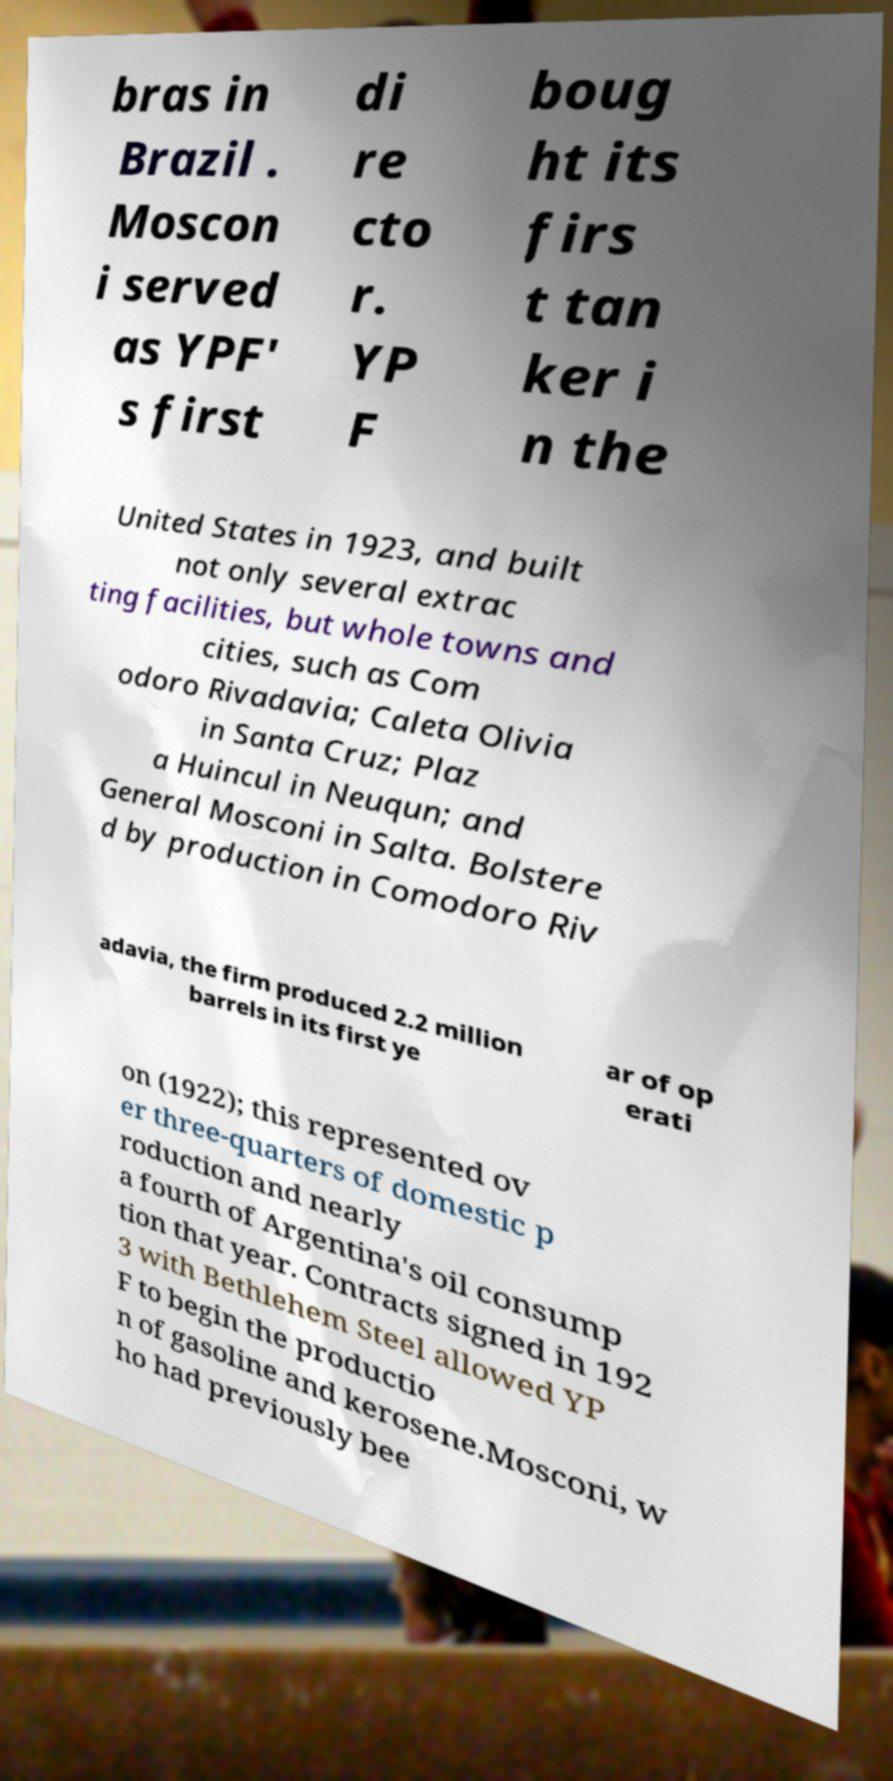What messages or text are displayed in this image? I need them in a readable, typed format. bras in Brazil . Moscon i served as YPF' s first di re cto r. YP F boug ht its firs t tan ker i n the United States in 1923, and built not only several extrac ting facilities, but whole towns and cities, such as Com odoro Rivadavia; Caleta Olivia in Santa Cruz; Plaz a Huincul in Neuqun; and General Mosconi in Salta. Bolstere d by production in Comodoro Riv adavia, the firm produced 2.2 million barrels in its first ye ar of op erati on (1922); this represented ov er three-quarters of domestic p roduction and nearly a fourth of Argentina's oil consump tion that year. Contracts signed in 192 3 with Bethlehem Steel allowed YP F to begin the productio n of gasoline and kerosene.Mosconi, w ho had previously bee 